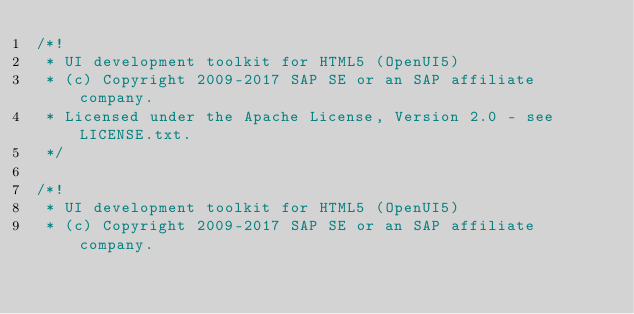<code> <loc_0><loc_0><loc_500><loc_500><_CSS_>/*!
 * UI development toolkit for HTML5 (OpenUI5)
 * (c) Copyright 2009-2017 SAP SE or an SAP affiliate company.
 * Licensed under the Apache License, Version 2.0 - see LICENSE.txt.
 */
 
/*!
 * UI development toolkit for HTML5 (OpenUI5)
 * (c) Copyright 2009-2017 SAP SE or an SAP affiliate company.</code> 